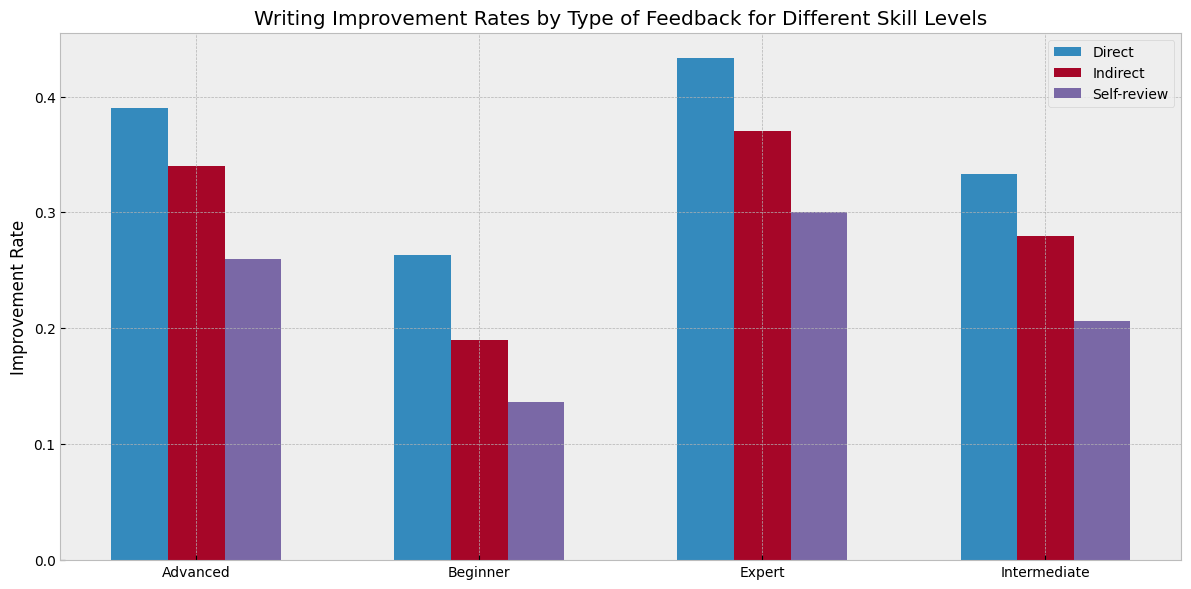What type of feedback shows the highest improvement rate for beginner writers? To determine the highest improvement rate for beginner writers, examine the bars corresponding to 'Beginner' across the 'Direct', 'Indirect', and 'Self-review' feedback types. The tallest bar, which represents the highest rate, corresponds to the 'Direct' feedback type.
Answer: Direct Which skill level benefits the most from indirect feedback? Compare the heights of the bars labeled as 'Indirect' across different skill levels. The tallest 'Indirect' bar is associated with 'Expert' skill levels.
Answer: Expert What is the improvement rate difference between direct and self-review feedback for intermediate writers? First, identify the heights of the bars for 'Direct' and 'Self-review' feedback for intermediate writers. 'Direct' has an average improvement rate of 0.33 and 'Self-review' has 0.21. Calculate the difference: 0.33 - 0.21 = 0.12.
Answer: 0.12 On average, which feedback type shows the least improvement across all skill levels? Sum all the improvement rates for each feedback type across the different skill levels and then compare the sums. 'Direct' feedback has sums approximating 0.33, 0.34, 0.36, and 0.429, 'Indirect' has sums approximating 0.27, 0.29, 0.32, and 0.37, while 'Self-review' has rates of 0.18, 0.21, 0.26, and 0.263. 'Self-review' shows consistently lower sums.
Answer: Self-review How does the improvement rate for self-review feedback change from beginner to expert writers? Examine the heights of the bars for 'Self-review' feedback from 'Beginner' to 'Expert'. The values are approximately 0.14 for 'Beginner', 0.21 for 'Intermediate', 0.26 for 'Advanced', and 0.30 for 'Expert'. There is a clear increasing trend.
Answer: Increases Which feedback type shows the most consistent improvement rate across different skill levels? Look at the uniformity in the heights of the bars for each feedback type across skill levels. 'Direct' feedback bars show less variability and a more consistent pattern compared to 'Indirect' or 'Self-review' feedback bars.
Answer: Direct What is the total improvement rate of all feedback types for 'Expert' skill levels? Find the rates of all feedback types for 'Expert': Direct (0.43), Indirect (0.37), and Self-review (0.30). Sum them up: 0.43 + 0.37 + 0.30 = 1.1.
Answer: 1.1 For which skill level is the improvement rate difference between direct and indirect feedback the smallest? Calculate the differences between 'Direct' and 'Indirect' bars for each skill level. The differences are approximately: Beginner (0.07), Intermediate (0.05), Advanced (0.05), Expert (0.06). The smallest difference is seen for 'Intermediate' and 'Advanced'.
Answer: Intermediate and Advanced 